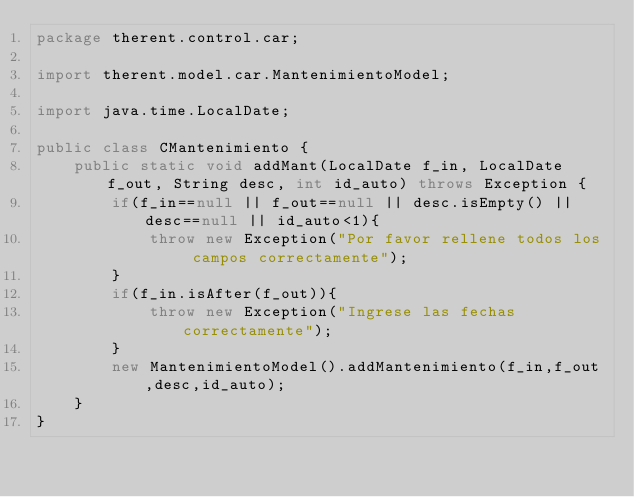Convert code to text. <code><loc_0><loc_0><loc_500><loc_500><_Java_>package therent.control.car;

import therent.model.car.MantenimientoModel;

import java.time.LocalDate;

public class CMantenimiento {
    public static void addMant(LocalDate f_in, LocalDate f_out, String desc, int id_auto) throws Exception {
        if(f_in==null || f_out==null || desc.isEmpty() || desc==null || id_auto<1){
            throw new Exception("Por favor rellene todos los campos correctamente");
        }
        if(f_in.isAfter(f_out)){
            throw new Exception("Ingrese las fechas correctamente");
        }
        new MantenimientoModel().addMantenimiento(f_in,f_out,desc,id_auto);
    }
}
</code> 